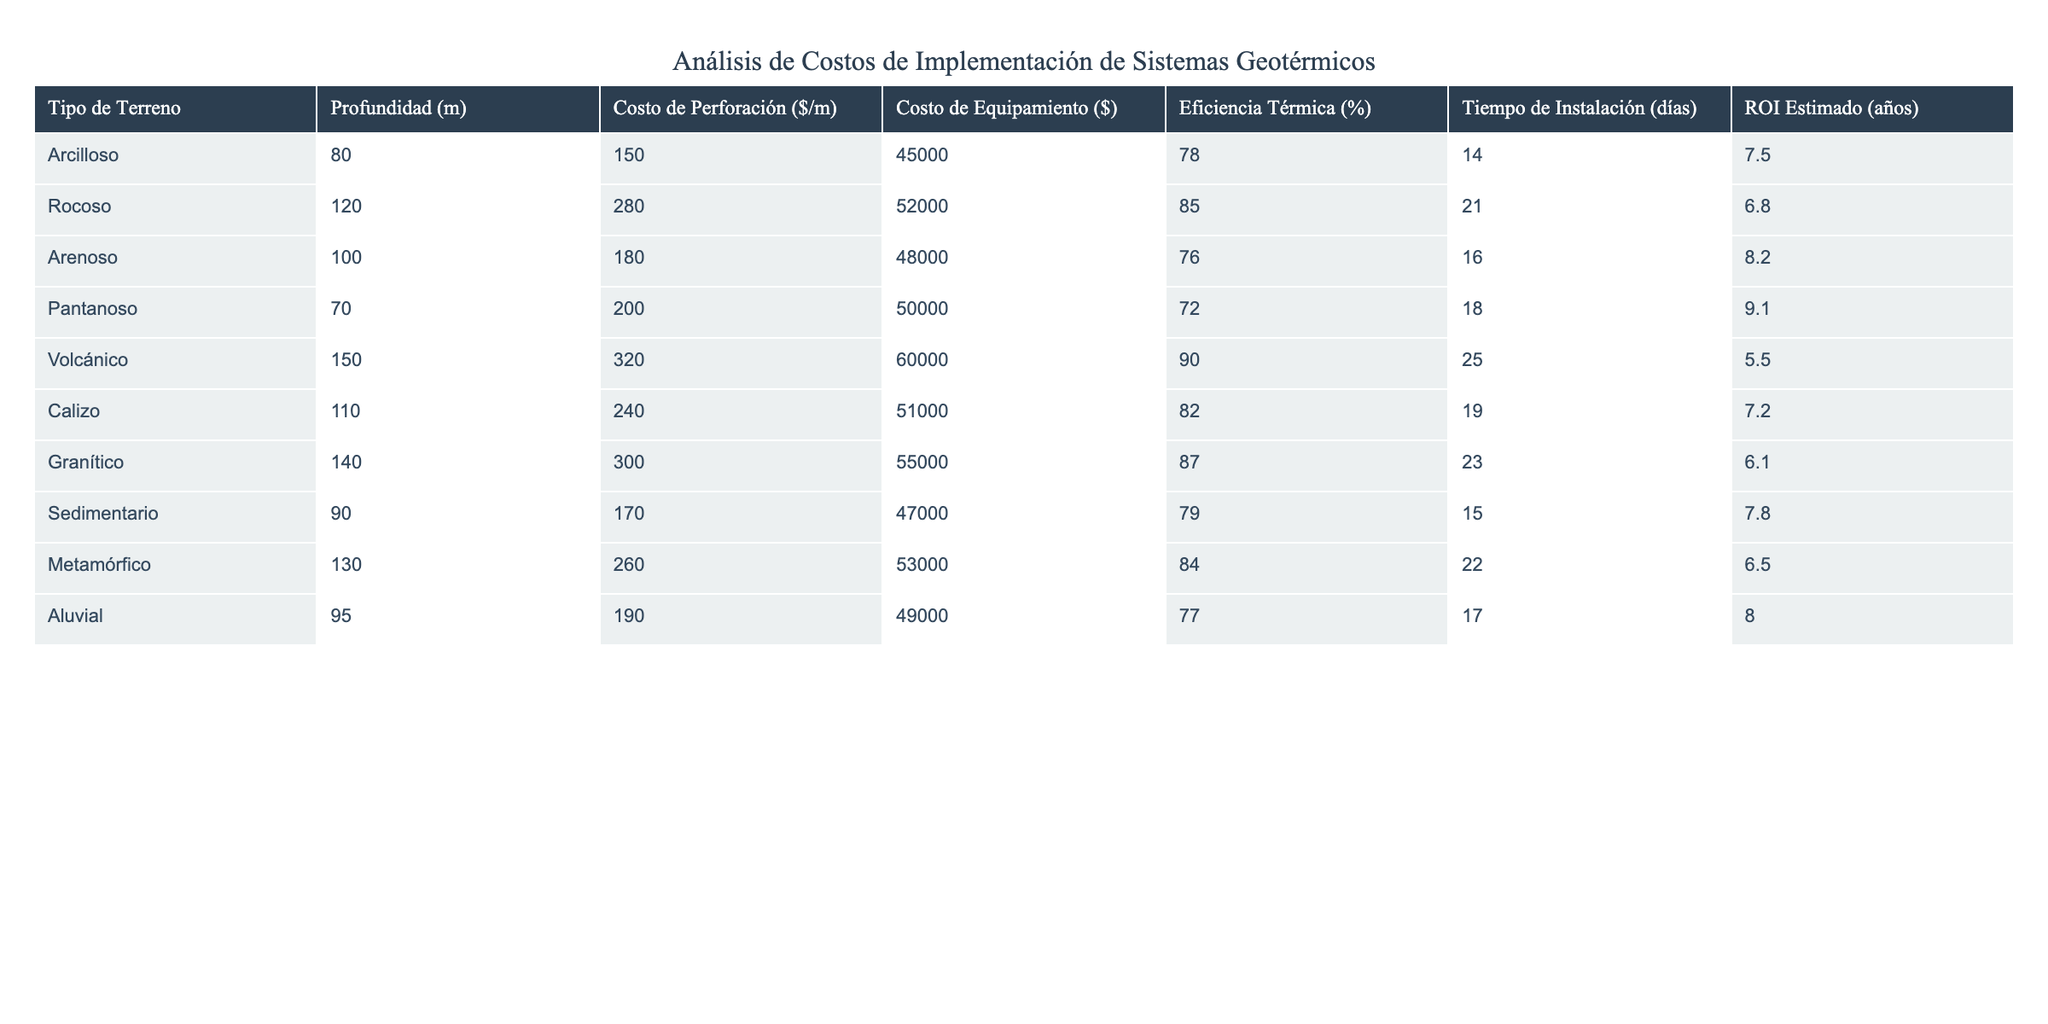¿Cuál es el costo de perforación por metro para terrenos volcánicos? En la tabla, busco el valor en la columna "Costo de Perforación ($/m)" para el tipo de terreno "Volcánico". Este valor se encuentra registrado como 320.
Answer: 320 ¿Cuál es la eficiencia térmica promedio de todos los terrenos? Para calcular la eficiencia térmica promedio, sumo los porcentajes de eficiencia térmica de todos los terrenos y divido entre el número total de terrenos. Los valores son (78 + 85 + 76 + 72 + 90 + 82 + 87 + 79 + 84 + 77) = 819, y hay 10 terrenos. Entonces, 819/10 = 81.9.
Answer: 81.9 ¿El terreno arenoso tiene un costo de equipamiento superior al de los terrenos pantanoso y sedimentario? Comparo el costo de equipamiento del terreno arenoso (48000) con el de los terrenos pantanoso (50000) y sedimentario (47000). Aquí, el terreno arenoso tiene un costo menor que el pantanoso, pero mayor que el sedimentario, por lo que la afirmación es falsa.
Answer: No ¿Cuál terreno presenta el mayor tiempo de instalación? Reviso la columna "Tiempo de Instalación (días)" para encontrar el valor máximo. El terreno volcánico tiene 25 días, que es el mayor tiempo de instalación registrado.
Answer: Volcánico ¿Cuál es la diferencia en los costos de perforación entre el terreno rocoso y el terreno arcilloso? Encuentro el costo de perforación del terreno rocoso (280) y del arcilloso (150). Luego, restando 280 - 150, la diferencia es de 130.
Answer: 130 ¿Cuál es el retorno de inversión más bajo y qué tipo de terreno lo tiene? Reviso la columna "ROI Estimado (años)" para identificar el menor valor. El retorno de inversión más bajo es 5.5 años, que corresponde al terreno volcánico.
Answer: Volcánico Si se suman los costos de perforación de los terrenos aluvial y calizo, ¿cuál es el total? Identifico los costos de perforación del terreno aluvial (190) y del calizo (240). Sumando ambos, obtengo 190 + 240 = 430.
Answer: 430 ¿Qué terreno tiene el mejor retorno de inversión? Busco en la columna "ROI Estimado (años)" el valor más alto. El mayor ROI es de 9.1 años, correspondiente al terreno pantanoso.
Answer: Pantanoso ¿Cuántos terrenos tienen una eficiencia térmica superior al 80%? Reviso la columna de eficiencia térmica y cuento todos los terrenos que presentan un porcentaje superior al 80%. Esto incluye los terrenos rocoso (85), volcánico (90), granítico (87), y metamórfico (84), totalizando 4 terrenos.
Answer: 4 ¿Es cierto que el terreno sedimentario tiene un costo de perforación menor que el terreno arenoso? Comparo los costos de perforación: sedimentario (170) y arenoso (180). El valor del terreno sedimentario es menor que el arenoso, por lo tanto es cierto.
Answer: Sí 